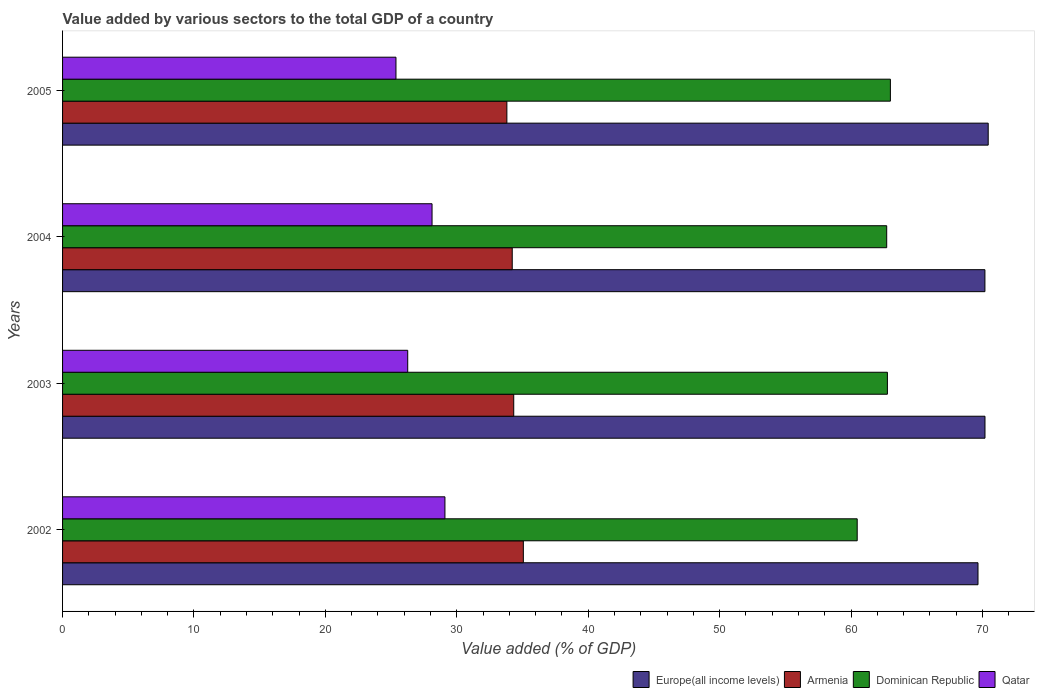How many bars are there on the 2nd tick from the top?
Your response must be concise. 4. How many bars are there on the 4th tick from the bottom?
Your answer should be very brief. 4. What is the label of the 2nd group of bars from the top?
Make the answer very short. 2004. What is the value added by various sectors to the total GDP in Dominican Republic in 2005?
Keep it short and to the point. 62.99. Across all years, what is the maximum value added by various sectors to the total GDP in Qatar?
Your answer should be very brief. 29.1. Across all years, what is the minimum value added by various sectors to the total GDP in Europe(all income levels)?
Your response must be concise. 69.66. In which year was the value added by various sectors to the total GDP in Dominican Republic maximum?
Offer a terse response. 2005. In which year was the value added by various sectors to the total GDP in Dominican Republic minimum?
Keep it short and to the point. 2002. What is the total value added by various sectors to the total GDP in Armenia in the graph?
Give a very brief answer. 137.42. What is the difference between the value added by various sectors to the total GDP in Dominican Republic in 2002 and that in 2004?
Make the answer very short. -2.25. What is the difference between the value added by various sectors to the total GDP in Armenia in 2005 and the value added by various sectors to the total GDP in Qatar in 2003?
Your answer should be compact. 7.54. What is the average value added by various sectors to the total GDP in Armenia per year?
Keep it short and to the point. 34.35. In the year 2002, what is the difference between the value added by various sectors to the total GDP in Armenia and value added by various sectors to the total GDP in Qatar?
Your answer should be very brief. 5.97. In how many years, is the value added by various sectors to the total GDP in Armenia greater than 56 %?
Give a very brief answer. 0. What is the ratio of the value added by various sectors to the total GDP in Europe(all income levels) in 2003 to that in 2004?
Give a very brief answer. 1. Is the difference between the value added by various sectors to the total GDP in Armenia in 2002 and 2005 greater than the difference between the value added by various sectors to the total GDP in Qatar in 2002 and 2005?
Ensure brevity in your answer.  No. What is the difference between the highest and the second highest value added by various sectors to the total GDP in Qatar?
Ensure brevity in your answer.  0.98. What is the difference between the highest and the lowest value added by various sectors to the total GDP in Dominican Republic?
Your response must be concise. 2.53. Is it the case that in every year, the sum of the value added by various sectors to the total GDP in Qatar and value added by various sectors to the total GDP in Europe(all income levels) is greater than the sum of value added by various sectors to the total GDP in Dominican Republic and value added by various sectors to the total GDP in Armenia?
Provide a short and direct response. Yes. What does the 4th bar from the top in 2003 represents?
Your answer should be compact. Europe(all income levels). What does the 3rd bar from the bottom in 2004 represents?
Give a very brief answer. Dominican Republic. Is it the case that in every year, the sum of the value added by various sectors to the total GDP in Armenia and value added by various sectors to the total GDP in Qatar is greater than the value added by various sectors to the total GDP in Europe(all income levels)?
Ensure brevity in your answer.  No. How many bars are there?
Ensure brevity in your answer.  16. What is the difference between two consecutive major ticks on the X-axis?
Provide a short and direct response. 10. Are the values on the major ticks of X-axis written in scientific E-notation?
Provide a short and direct response. No. Does the graph contain any zero values?
Your answer should be compact. No. Does the graph contain grids?
Make the answer very short. No. Where does the legend appear in the graph?
Give a very brief answer. Bottom right. How many legend labels are there?
Offer a very short reply. 4. What is the title of the graph?
Your answer should be very brief. Value added by various sectors to the total GDP of a country. What is the label or title of the X-axis?
Ensure brevity in your answer.  Value added (% of GDP). What is the Value added (% of GDP) in Europe(all income levels) in 2002?
Offer a terse response. 69.66. What is the Value added (% of GDP) of Armenia in 2002?
Make the answer very short. 35.06. What is the Value added (% of GDP) of Dominican Republic in 2002?
Your answer should be compact. 60.47. What is the Value added (% of GDP) in Qatar in 2002?
Your answer should be compact. 29.1. What is the Value added (% of GDP) of Europe(all income levels) in 2003?
Your answer should be compact. 70.19. What is the Value added (% of GDP) of Armenia in 2003?
Give a very brief answer. 34.33. What is the Value added (% of GDP) of Dominican Republic in 2003?
Make the answer very short. 62.76. What is the Value added (% of GDP) of Qatar in 2003?
Keep it short and to the point. 26.26. What is the Value added (% of GDP) in Europe(all income levels) in 2004?
Your response must be concise. 70.19. What is the Value added (% of GDP) in Armenia in 2004?
Ensure brevity in your answer.  34.22. What is the Value added (% of GDP) in Dominican Republic in 2004?
Your answer should be very brief. 62.71. What is the Value added (% of GDP) in Qatar in 2004?
Your response must be concise. 28.12. What is the Value added (% of GDP) of Europe(all income levels) in 2005?
Offer a very short reply. 70.44. What is the Value added (% of GDP) of Armenia in 2005?
Your answer should be compact. 33.81. What is the Value added (% of GDP) in Dominican Republic in 2005?
Your answer should be very brief. 62.99. What is the Value added (% of GDP) of Qatar in 2005?
Your answer should be compact. 25.37. Across all years, what is the maximum Value added (% of GDP) in Europe(all income levels)?
Ensure brevity in your answer.  70.44. Across all years, what is the maximum Value added (% of GDP) in Armenia?
Keep it short and to the point. 35.06. Across all years, what is the maximum Value added (% of GDP) of Dominican Republic?
Offer a very short reply. 62.99. Across all years, what is the maximum Value added (% of GDP) of Qatar?
Ensure brevity in your answer.  29.1. Across all years, what is the minimum Value added (% of GDP) of Europe(all income levels)?
Provide a short and direct response. 69.66. Across all years, what is the minimum Value added (% of GDP) in Armenia?
Provide a short and direct response. 33.81. Across all years, what is the minimum Value added (% of GDP) in Dominican Republic?
Your answer should be very brief. 60.47. Across all years, what is the minimum Value added (% of GDP) in Qatar?
Give a very brief answer. 25.37. What is the total Value added (% of GDP) in Europe(all income levels) in the graph?
Make the answer very short. 280.47. What is the total Value added (% of GDP) in Armenia in the graph?
Offer a very short reply. 137.42. What is the total Value added (% of GDP) of Dominican Republic in the graph?
Provide a succinct answer. 248.94. What is the total Value added (% of GDP) in Qatar in the graph?
Your answer should be very brief. 108.85. What is the difference between the Value added (% of GDP) of Europe(all income levels) in 2002 and that in 2003?
Provide a short and direct response. -0.53. What is the difference between the Value added (% of GDP) in Armenia in 2002 and that in 2003?
Give a very brief answer. 0.73. What is the difference between the Value added (% of GDP) of Dominican Republic in 2002 and that in 2003?
Ensure brevity in your answer.  -2.3. What is the difference between the Value added (% of GDP) in Qatar in 2002 and that in 2003?
Your response must be concise. 2.83. What is the difference between the Value added (% of GDP) of Europe(all income levels) in 2002 and that in 2004?
Your answer should be compact. -0.53. What is the difference between the Value added (% of GDP) of Armenia in 2002 and that in 2004?
Ensure brevity in your answer.  0.85. What is the difference between the Value added (% of GDP) of Dominican Republic in 2002 and that in 2004?
Your answer should be very brief. -2.25. What is the difference between the Value added (% of GDP) in Qatar in 2002 and that in 2004?
Your answer should be very brief. 0.98. What is the difference between the Value added (% of GDP) in Europe(all income levels) in 2002 and that in 2005?
Offer a terse response. -0.78. What is the difference between the Value added (% of GDP) in Armenia in 2002 and that in 2005?
Your response must be concise. 1.25. What is the difference between the Value added (% of GDP) of Dominican Republic in 2002 and that in 2005?
Offer a terse response. -2.53. What is the difference between the Value added (% of GDP) of Qatar in 2002 and that in 2005?
Offer a very short reply. 3.73. What is the difference between the Value added (% of GDP) of Europe(all income levels) in 2003 and that in 2004?
Provide a short and direct response. 0. What is the difference between the Value added (% of GDP) of Armenia in 2003 and that in 2004?
Your response must be concise. 0.11. What is the difference between the Value added (% of GDP) in Dominican Republic in 2003 and that in 2004?
Your answer should be compact. 0.05. What is the difference between the Value added (% of GDP) in Qatar in 2003 and that in 2004?
Your response must be concise. -1.85. What is the difference between the Value added (% of GDP) in Europe(all income levels) in 2003 and that in 2005?
Make the answer very short. -0.24. What is the difference between the Value added (% of GDP) in Armenia in 2003 and that in 2005?
Provide a short and direct response. 0.52. What is the difference between the Value added (% of GDP) in Dominican Republic in 2003 and that in 2005?
Your response must be concise. -0.23. What is the difference between the Value added (% of GDP) of Qatar in 2003 and that in 2005?
Keep it short and to the point. 0.89. What is the difference between the Value added (% of GDP) of Europe(all income levels) in 2004 and that in 2005?
Make the answer very short. -0.25. What is the difference between the Value added (% of GDP) of Armenia in 2004 and that in 2005?
Your answer should be compact. 0.41. What is the difference between the Value added (% of GDP) of Dominican Republic in 2004 and that in 2005?
Provide a short and direct response. -0.28. What is the difference between the Value added (% of GDP) of Qatar in 2004 and that in 2005?
Make the answer very short. 2.75. What is the difference between the Value added (% of GDP) in Europe(all income levels) in 2002 and the Value added (% of GDP) in Armenia in 2003?
Your answer should be very brief. 35.33. What is the difference between the Value added (% of GDP) in Europe(all income levels) in 2002 and the Value added (% of GDP) in Dominican Republic in 2003?
Your response must be concise. 6.89. What is the difference between the Value added (% of GDP) in Europe(all income levels) in 2002 and the Value added (% of GDP) in Qatar in 2003?
Your answer should be very brief. 43.39. What is the difference between the Value added (% of GDP) of Armenia in 2002 and the Value added (% of GDP) of Dominican Republic in 2003?
Provide a succinct answer. -27.7. What is the difference between the Value added (% of GDP) in Armenia in 2002 and the Value added (% of GDP) in Qatar in 2003?
Ensure brevity in your answer.  8.8. What is the difference between the Value added (% of GDP) of Dominican Republic in 2002 and the Value added (% of GDP) of Qatar in 2003?
Your response must be concise. 34.2. What is the difference between the Value added (% of GDP) in Europe(all income levels) in 2002 and the Value added (% of GDP) in Armenia in 2004?
Ensure brevity in your answer.  35.44. What is the difference between the Value added (% of GDP) in Europe(all income levels) in 2002 and the Value added (% of GDP) in Dominican Republic in 2004?
Keep it short and to the point. 6.95. What is the difference between the Value added (% of GDP) in Europe(all income levels) in 2002 and the Value added (% of GDP) in Qatar in 2004?
Your response must be concise. 41.54. What is the difference between the Value added (% of GDP) in Armenia in 2002 and the Value added (% of GDP) in Dominican Republic in 2004?
Offer a very short reply. -27.65. What is the difference between the Value added (% of GDP) of Armenia in 2002 and the Value added (% of GDP) of Qatar in 2004?
Provide a short and direct response. 6.95. What is the difference between the Value added (% of GDP) in Dominican Republic in 2002 and the Value added (% of GDP) in Qatar in 2004?
Offer a very short reply. 32.35. What is the difference between the Value added (% of GDP) in Europe(all income levels) in 2002 and the Value added (% of GDP) in Armenia in 2005?
Make the answer very short. 35.85. What is the difference between the Value added (% of GDP) of Europe(all income levels) in 2002 and the Value added (% of GDP) of Dominican Republic in 2005?
Your response must be concise. 6.67. What is the difference between the Value added (% of GDP) in Europe(all income levels) in 2002 and the Value added (% of GDP) in Qatar in 2005?
Your answer should be compact. 44.29. What is the difference between the Value added (% of GDP) of Armenia in 2002 and the Value added (% of GDP) of Dominican Republic in 2005?
Ensure brevity in your answer.  -27.93. What is the difference between the Value added (% of GDP) of Armenia in 2002 and the Value added (% of GDP) of Qatar in 2005?
Make the answer very short. 9.69. What is the difference between the Value added (% of GDP) in Dominican Republic in 2002 and the Value added (% of GDP) in Qatar in 2005?
Make the answer very short. 35.1. What is the difference between the Value added (% of GDP) in Europe(all income levels) in 2003 and the Value added (% of GDP) in Armenia in 2004?
Your response must be concise. 35.97. What is the difference between the Value added (% of GDP) of Europe(all income levels) in 2003 and the Value added (% of GDP) of Dominican Republic in 2004?
Your answer should be very brief. 7.48. What is the difference between the Value added (% of GDP) of Europe(all income levels) in 2003 and the Value added (% of GDP) of Qatar in 2004?
Provide a short and direct response. 42.08. What is the difference between the Value added (% of GDP) in Armenia in 2003 and the Value added (% of GDP) in Dominican Republic in 2004?
Provide a succinct answer. -28.38. What is the difference between the Value added (% of GDP) in Armenia in 2003 and the Value added (% of GDP) in Qatar in 2004?
Provide a short and direct response. 6.21. What is the difference between the Value added (% of GDP) in Dominican Republic in 2003 and the Value added (% of GDP) in Qatar in 2004?
Give a very brief answer. 34.65. What is the difference between the Value added (% of GDP) in Europe(all income levels) in 2003 and the Value added (% of GDP) in Armenia in 2005?
Your answer should be very brief. 36.38. What is the difference between the Value added (% of GDP) of Europe(all income levels) in 2003 and the Value added (% of GDP) of Dominican Republic in 2005?
Offer a terse response. 7.2. What is the difference between the Value added (% of GDP) of Europe(all income levels) in 2003 and the Value added (% of GDP) of Qatar in 2005?
Keep it short and to the point. 44.82. What is the difference between the Value added (% of GDP) of Armenia in 2003 and the Value added (% of GDP) of Dominican Republic in 2005?
Keep it short and to the point. -28.66. What is the difference between the Value added (% of GDP) of Armenia in 2003 and the Value added (% of GDP) of Qatar in 2005?
Ensure brevity in your answer.  8.96. What is the difference between the Value added (% of GDP) in Dominican Republic in 2003 and the Value added (% of GDP) in Qatar in 2005?
Keep it short and to the point. 37.4. What is the difference between the Value added (% of GDP) of Europe(all income levels) in 2004 and the Value added (% of GDP) of Armenia in 2005?
Provide a short and direct response. 36.38. What is the difference between the Value added (% of GDP) in Europe(all income levels) in 2004 and the Value added (% of GDP) in Dominican Republic in 2005?
Offer a terse response. 7.19. What is the difference between the Value added (% of GDP) of Europe(all income levels) in 2004 and the Value added (% of GDP) of Qatar in 2005?
Offer a very short reply. 44.82. What is the difference between the Value added (% of GDP) in Armenia in 2004 and the Value added (% of GDP) in Dominican Republic in 2005?
Offer a very short reply. -28.78. What is the difference between the Value added (% of GDP) of Armenia in 2004 and the Value added (% of GDP) of Qatar in 2005?
Make the answer very short. 8.85. What is the difference between the Value added (% of GDP) of Dominican Republic in 2004 and the Value added (% of GDP) of Qatar in 2005?
Make the answer very short. 37.34. What is the average Value added (% of GDP) in Europe(all income levels) per year?
Your answer should be compact. 70.12. What is the average Value added (% of GDP) in Armenia per year?
Offer a very short reply. 34.35. What is the average Value added (% of GDP) in Dominican Republic per year?
Ensure brevity in your answer.  62.23. What is the average Value added (% of GDP) in Qatar per year?
Make the answer very short. 27.21. In the year 2002, what is the difference between the Value added (% of GDP) of Europe(all income levels) and Value added (% of GDP) of Armenia?
Keep it short and to the point. 34.6. In the year 2002, what is the difference between the Value added (% of GDP) of Europe(all income levels) and Value added (% of GDP) of Dominican Republic?
Keep it short and to the point. 9.19. In the year 2002, what is the difference between the Value added (% of GDP) in Europe(all income levels) and Value added (% of GDP) in Qatar?
Give a very brief answer. 40.56. In the year 2002, what is the difference between the Value added (% of GDP) in Armenia and Value added (% of GDP) in Dominican Republic?
Keep it short and to the point. -25.4. In the year 2002, what is the difference between the Value added (% of GDP) in Armenia and Value added (% of GDP) in Qatar?
Provide a short and direct response. 5.97. In the year 2002, what is the difference between the Value added (% of GDP) of Dominican Republic and Value added (% of GDP) of Qatar?
Keep it short and to the point. 31.37. In the year 2003, what is the difference between the Value added (% of GDP) of Europe(all income levels) and Value added (% of GDP) of Armenia?
Give a very brief answer. 35.86. In the year 2003, what is the difference between the Value added (% of GDP) in Europe(all income levels) and Value added (% of GDP) in Dominican Republic?
Provide a short and direct response. 7.43. In the year 2003, what is the difference between the Value added (% of GDP) of Europe(all income levels) and Value added (% of GDP) of Qatar?
Offer a terse response. 43.93. In the year 2003, what is the difference between the Value added (% of GDP) in Armenia and Value added (% of GDP) in Dominican Republic?
Your answer should be compact. -28.43. In the year 2003, what is the difference between the Value added (% of GDP) in Armenia and Value added (% of GDP) in Qatar?
Offer a terse response. 8.07. In the year 2003, what is the difference between the Value added (% of GDP) of Dominican Republic and Value added (% of GDP) of Qatar?
Offer a very short reply. 36.5. In the year 2004, what is the difference between the Value added (% of GDP) of Europe(all income levels) and Value added (% of GDP) of Armenia?
Provide a succinct answer. 35.97. In the year 2004, what is the difference between the Value added (% of GDP) in Europe(all income levels) and Value added (% of GDP) in Dominican Republic?
Keep it short and to the point. 7.47. In the year 2004, what is the difference between the Value added (% of GDP) in Europe(all income levels) and Value added (% of GDP) in Qatar?
Your answer should be compact. 42.07. In the year 2004, what is the difference between the Value added (% of GDP) in Armenia and Value added (% of GDP) in Dominican Republic?
Ensure brevity in your answer.  -28.5. In the year 2004, what is the difference between the Value added (% of GDP) of Armenia and Value added (% of GDP) of Qatar?
Provide a succinct answer. 6.1. In the year 2004, what is the difference between the Value added (% of GDP) in Dominican Republic and Value added (% of GDP) in Qatar?
Provide a succinct answer. 34.6. In the year 2005, what is the difference between the Value added (% of GDP) of Europe(all income levels) and Value added (% of GDP) of Armenia?
Offer a terse response. 36.63. In the year 2005, what is the difference between the Value added (% of GDP) in Europe(all income levels) and Value added (% of GDP) in Dominican Republic?
Make the answer very short. 7.44. In the year 2005, what is the difference between the Value added (% of GDP) of Europe(all income levels) and Value added (% of GDP) of Qatar?
Your answer should be very brief. 45.07. In the year 2005, what is the difference between the Value added (% of GDP) in Armenia and Value added (% of GDP) in Dominican Republic?
Ensure brevity in your answer.  -29.18. In the year 2005, what is the difference between the Value added (% of GDP) in Armenia and Value added (% of GDP) in Qatar?
Your answer should be very brief. 8.44. In the year 2005, what is the difference between the Value added (% of GDP) in Dominican Republic and Value added (% of GDP) in Qatar?
Offer a terse response. 37.62. What is the ratio of the Value added (% of GDP) of Armenia in 2002 to that in 2003?
Give a very brief answer. 1.02. What is the ratio of the Value added (% of GDP) in Dominican Republic in 2002 to that in 2003?
Ensure brevity in your answer.  0.96. What is the ratio of the Value added (% of GDP) of Qatar in 2002 to that in 2003?
Offer a very short reply. 1.11. What is the ratio of the Value added (% of GDP) in Europe(all income levels) in 2002 to that in 2004?
Offer a very short reply. 0.99. What is the ratio of the Value added (% of GDP) in Armenia in 2002 to that in 2004?
Provide a succinct answer. 1.02. What is the ratio of the Value added (% of GDP) of Dominican Republic in 2002 to that in 2004?
Give a very brief answer. 0.96. What is the ratio of the Value added (% of GDP) of Qatar in 2002 to that in 2004?
Give a very brief answer. 1.03. What is the ratio of the Value added (% of GDP) in Armenia in 2002 to that in 2005?
Keep it short and to the point. 1.04. What is the ratio of the Value added (% of GDP) of Dominican Republic in 2002 to that in 2005?
Provide a succinct answer. 0.96. What is the ratio of the Value added (% of GDP) in Qatar in 2002 to that in 2005?
Keep it short and to the point. 1.15. What is the ratio of the Value added (% of GDP) in Europe(all income levels) in 2003 to that in 2004?
Keep it short and to the point. 1. What is the ratio of the Value added (% of GDP) in Dominican Republic in 2003 to that in 2004?
Provide a short and direct response. 1. What is the ratio of the Value added (% of GDP) in Qatar in 2003 to that in 2004?
Make the answer very short. 0.93. What is the ratio of the Value added (% of GDP) in Europe(all income levels) in 2003 to that in 2005?
Offer a very short reply. 1. What is the ratio of the Value added (% of GDP) of Armenia in 2003 to that in 2005?
Keep it short and to the point. 1.02. What is the ratio of the Value added (% of GDP) in Qatar in 2003 to that in 2005?
Offer a terse response. 1.04. What is the ratio of the Value added (% of GDP) of Europe(all income levels) in 2004 to that in 2005?
Offer a terse response. 1. What is the ratio of the Value added (% of GDP) of Armenia in 2004 to that in 2005?
Ensure brevity in your answer.  1.01. What is the ratio of the Value added (% of GDP) of Dominican Republic in 2004 to that in 2005?
Offer a terse response. 1. What is the ratio of the Value added (% of GDP) of Qatar in 2004 to that in 2005?
Give a very brief answer. 1.11. What is the difference between the highest and the second highest Value added (% of GDP) of Europe(all income levels)?
Keep it short and to the point. 0.24. What is the difference between the highest and the second highest Value added (% of GDP) of Armenia?
Ensure brevity in your answer.  0.73. What is the difference between the highest and the second highest Value added (% of GDP) in Dominican Republic?
Ensure brevity in your answer.  0.23. What is the difference between the highest and the second highest Value added (% of GDP) of Qatar?
Give a very brief answer. 0.98. What is the difference between the highest and the lowest Value added (% of GDP) of Europe(all income levels)?
Provide a succinct answer. 0.78. What is the difference between the highest and the lowest Value added (% of GDP) of Armenia?
Your answer should be compact. 1.25. What is the difference between the highest and the lowest Value added (% of GDP) in Dominican Republic?
Keep it short and to the point. 2.53. What is the difference between the highest and the lowest Value added (% of GDP) in Qatar?
Offer a terse response. 3.73. 